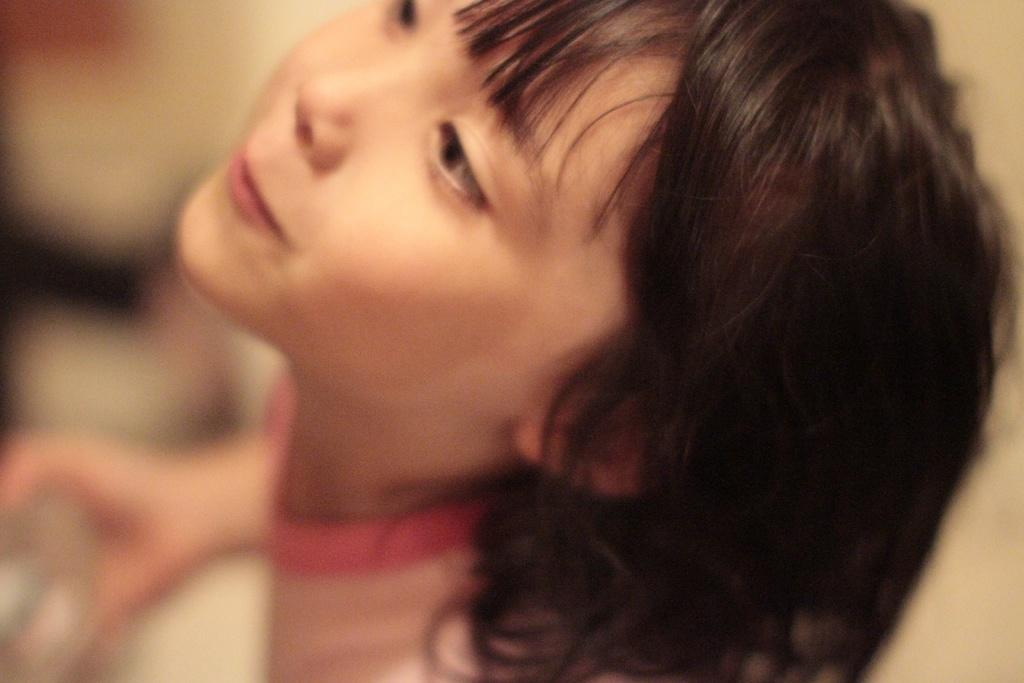Who is the main subject in the image? There is a girl in the image. What is the girl holding in her hand? The girl is holding an object in her hand. Can you describe the background of the image? The background of the image is blurry. What type of harbor can be seen in the background of the image? There is no harbor present in the image; the background is blurry. How does the girl walk in the image? The girl is not walking in the image; she is holding an object in her hand. 